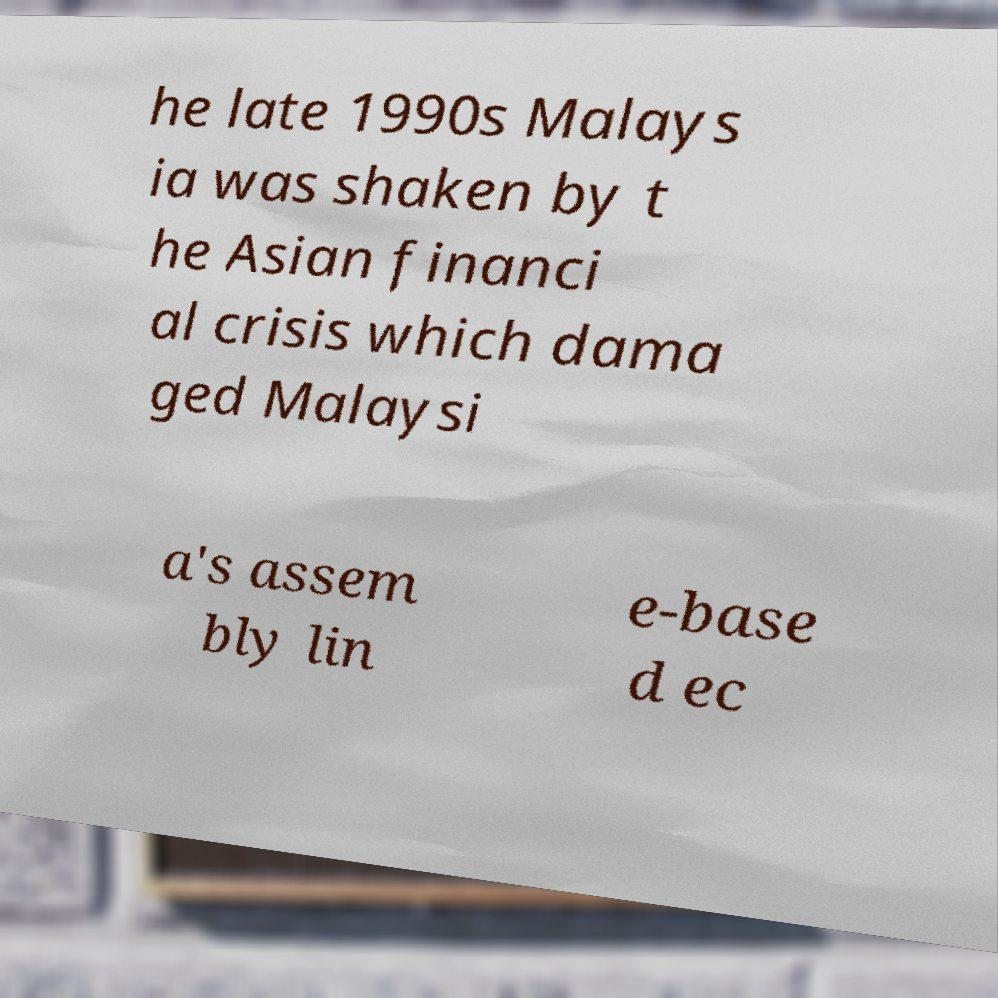What messages or text are displayed in this image? I need them in a readable, typed format. he late 1990s Malays ia was shaken by t he Asian financi al crisis which dama ged Malaysi a's assem bly lin e-base d ec 